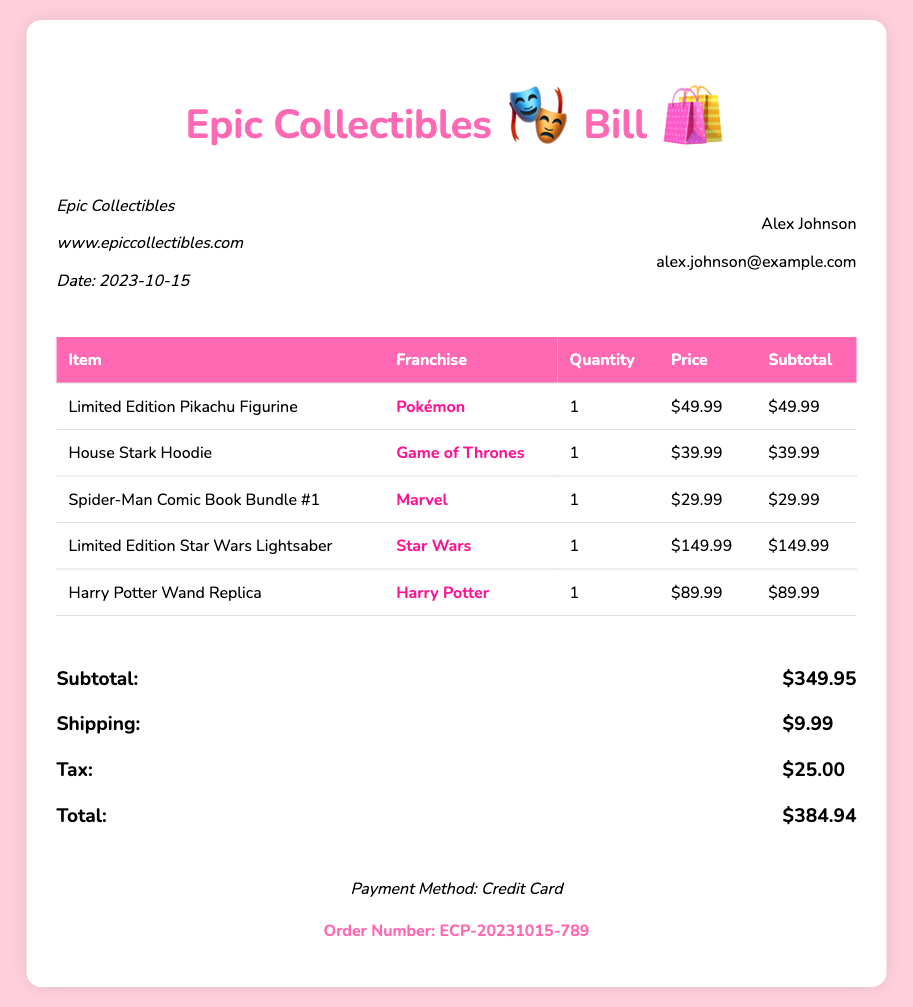what is the date of the bill? The date of the bill is mentioned in the document and is formatted as 2023-10-15.
Answer: 2023-10-15 who is the customer? The customer's name is provided in the customer information section of the document.
Answer: Alex Johnson what is the subtotal amount? The subtotal amount is listed in the total section of the document.
Answer: $349.95 how many items were purchased? There are five items listed in the purchase table in the document.
Answer: 5 what is the total amount due? The total amount due is calculated in the total section of the document, including subtotal, shipping, and tax.
Answer: $384.94 what payment method was used? The payment method is stated near the bottom of the document.
Answer: Credit Card which franchise does the limited edition lightsaber belong to? The franchise for the limited edition lightsaber is specified in the table under the franchise column.
Answer: Star Wars how much was the shipping cost? The shipping cost is detailed in the total section of the document.
Answer: $9.99 what is the order number? The order number is clearly indicated at the bottom of the document.
Answer: ECP-20231015-789 